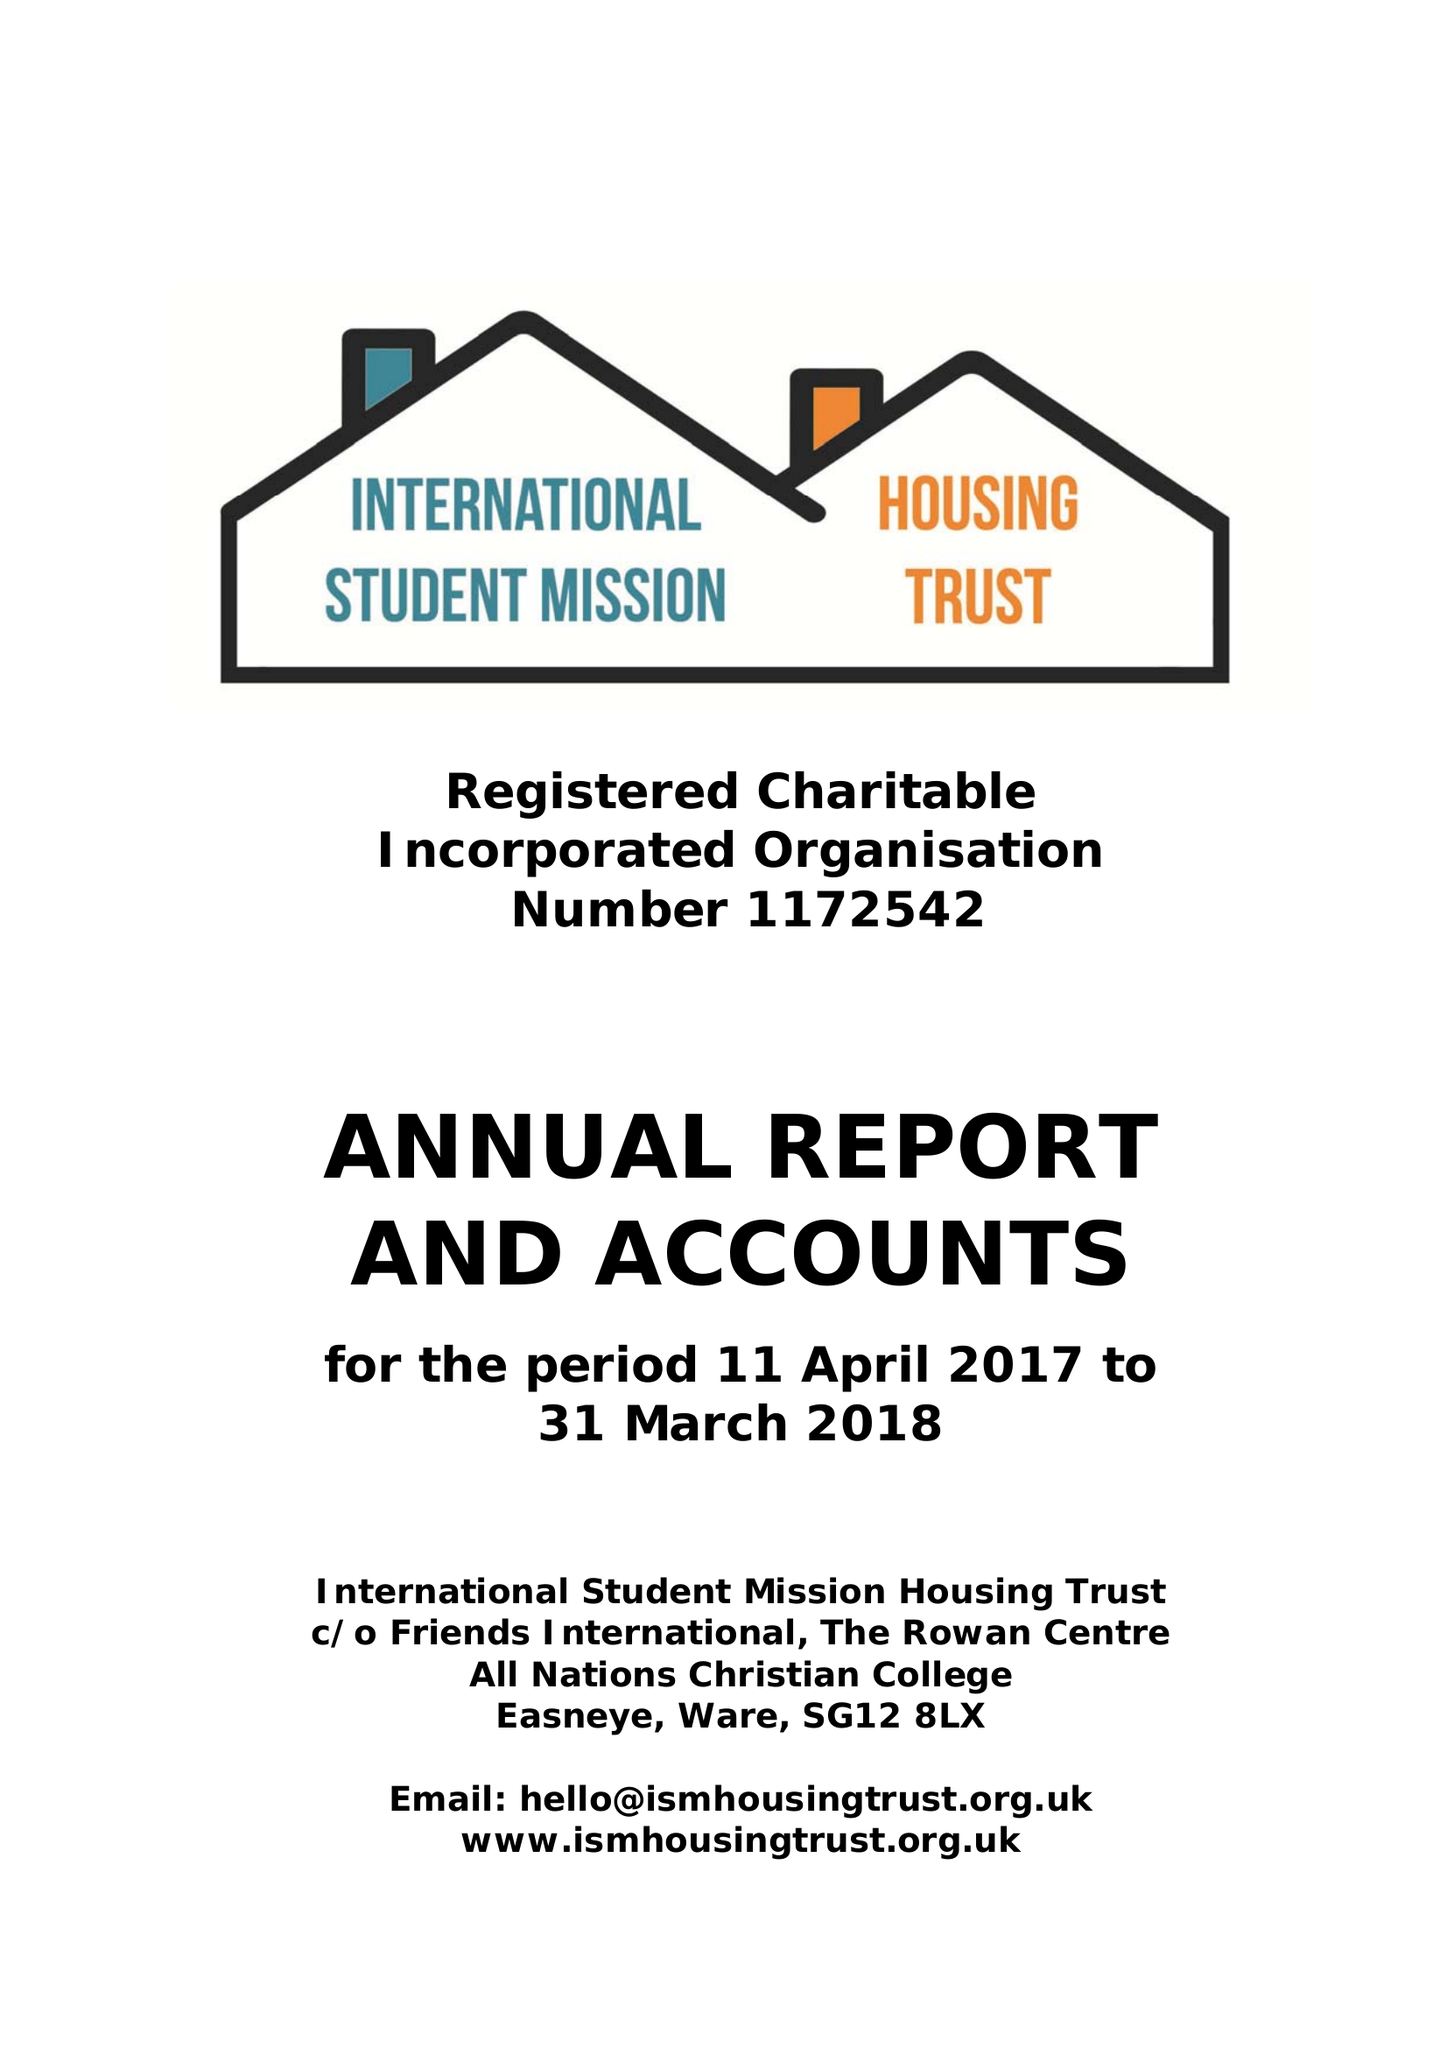What is the value for the address__street_line?
Answer the question using a single word or phrase. None 